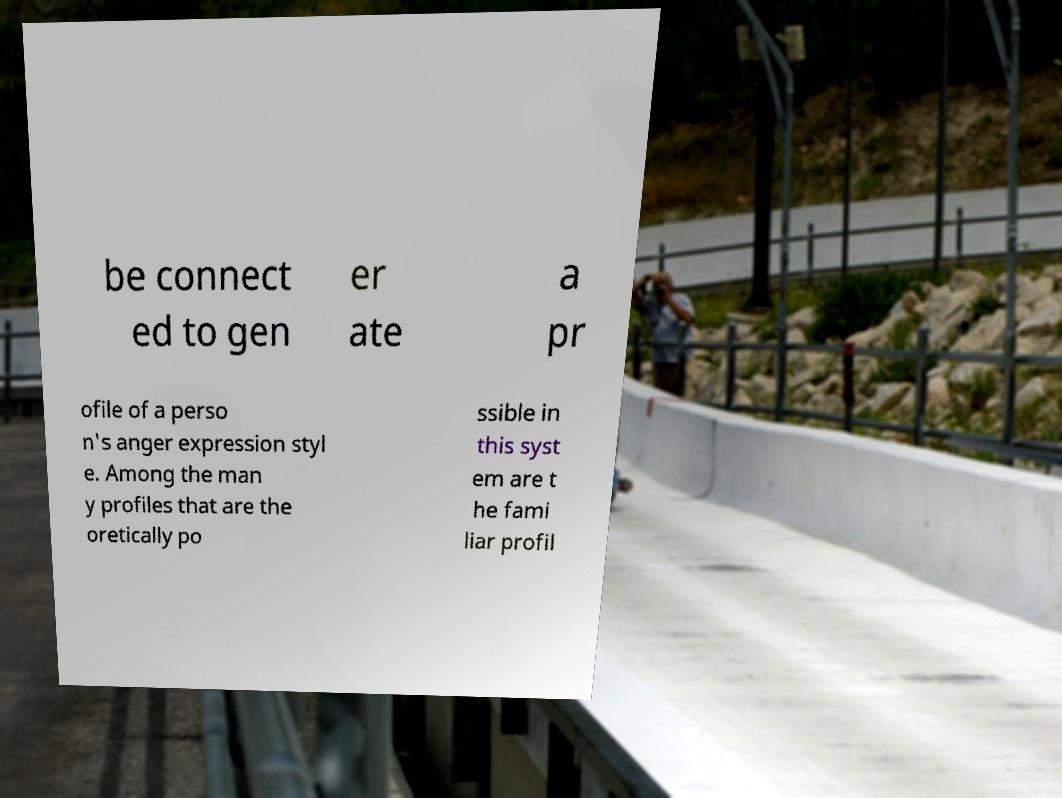Please identify and transcribe the text found in this image. be connect ed to gen er ate a pr ofile of a perso n's anger expression styl e. Among the man y profiles that are the oretically po ssible in this syst em are t he fami liar profil 